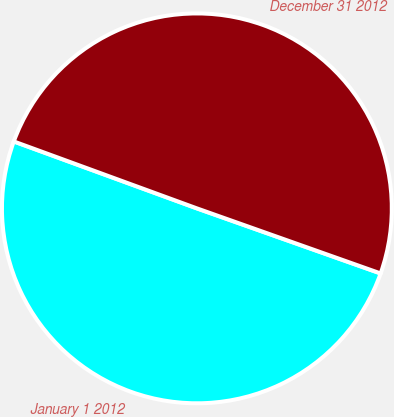<chart> <loc_0><loc_0><loc_500><loc_500><pie_chart><fcel>January 1 2012<fcel>December 31 2012<nl><fcel>50.16%<fcel>49.84%<nl></chart> 